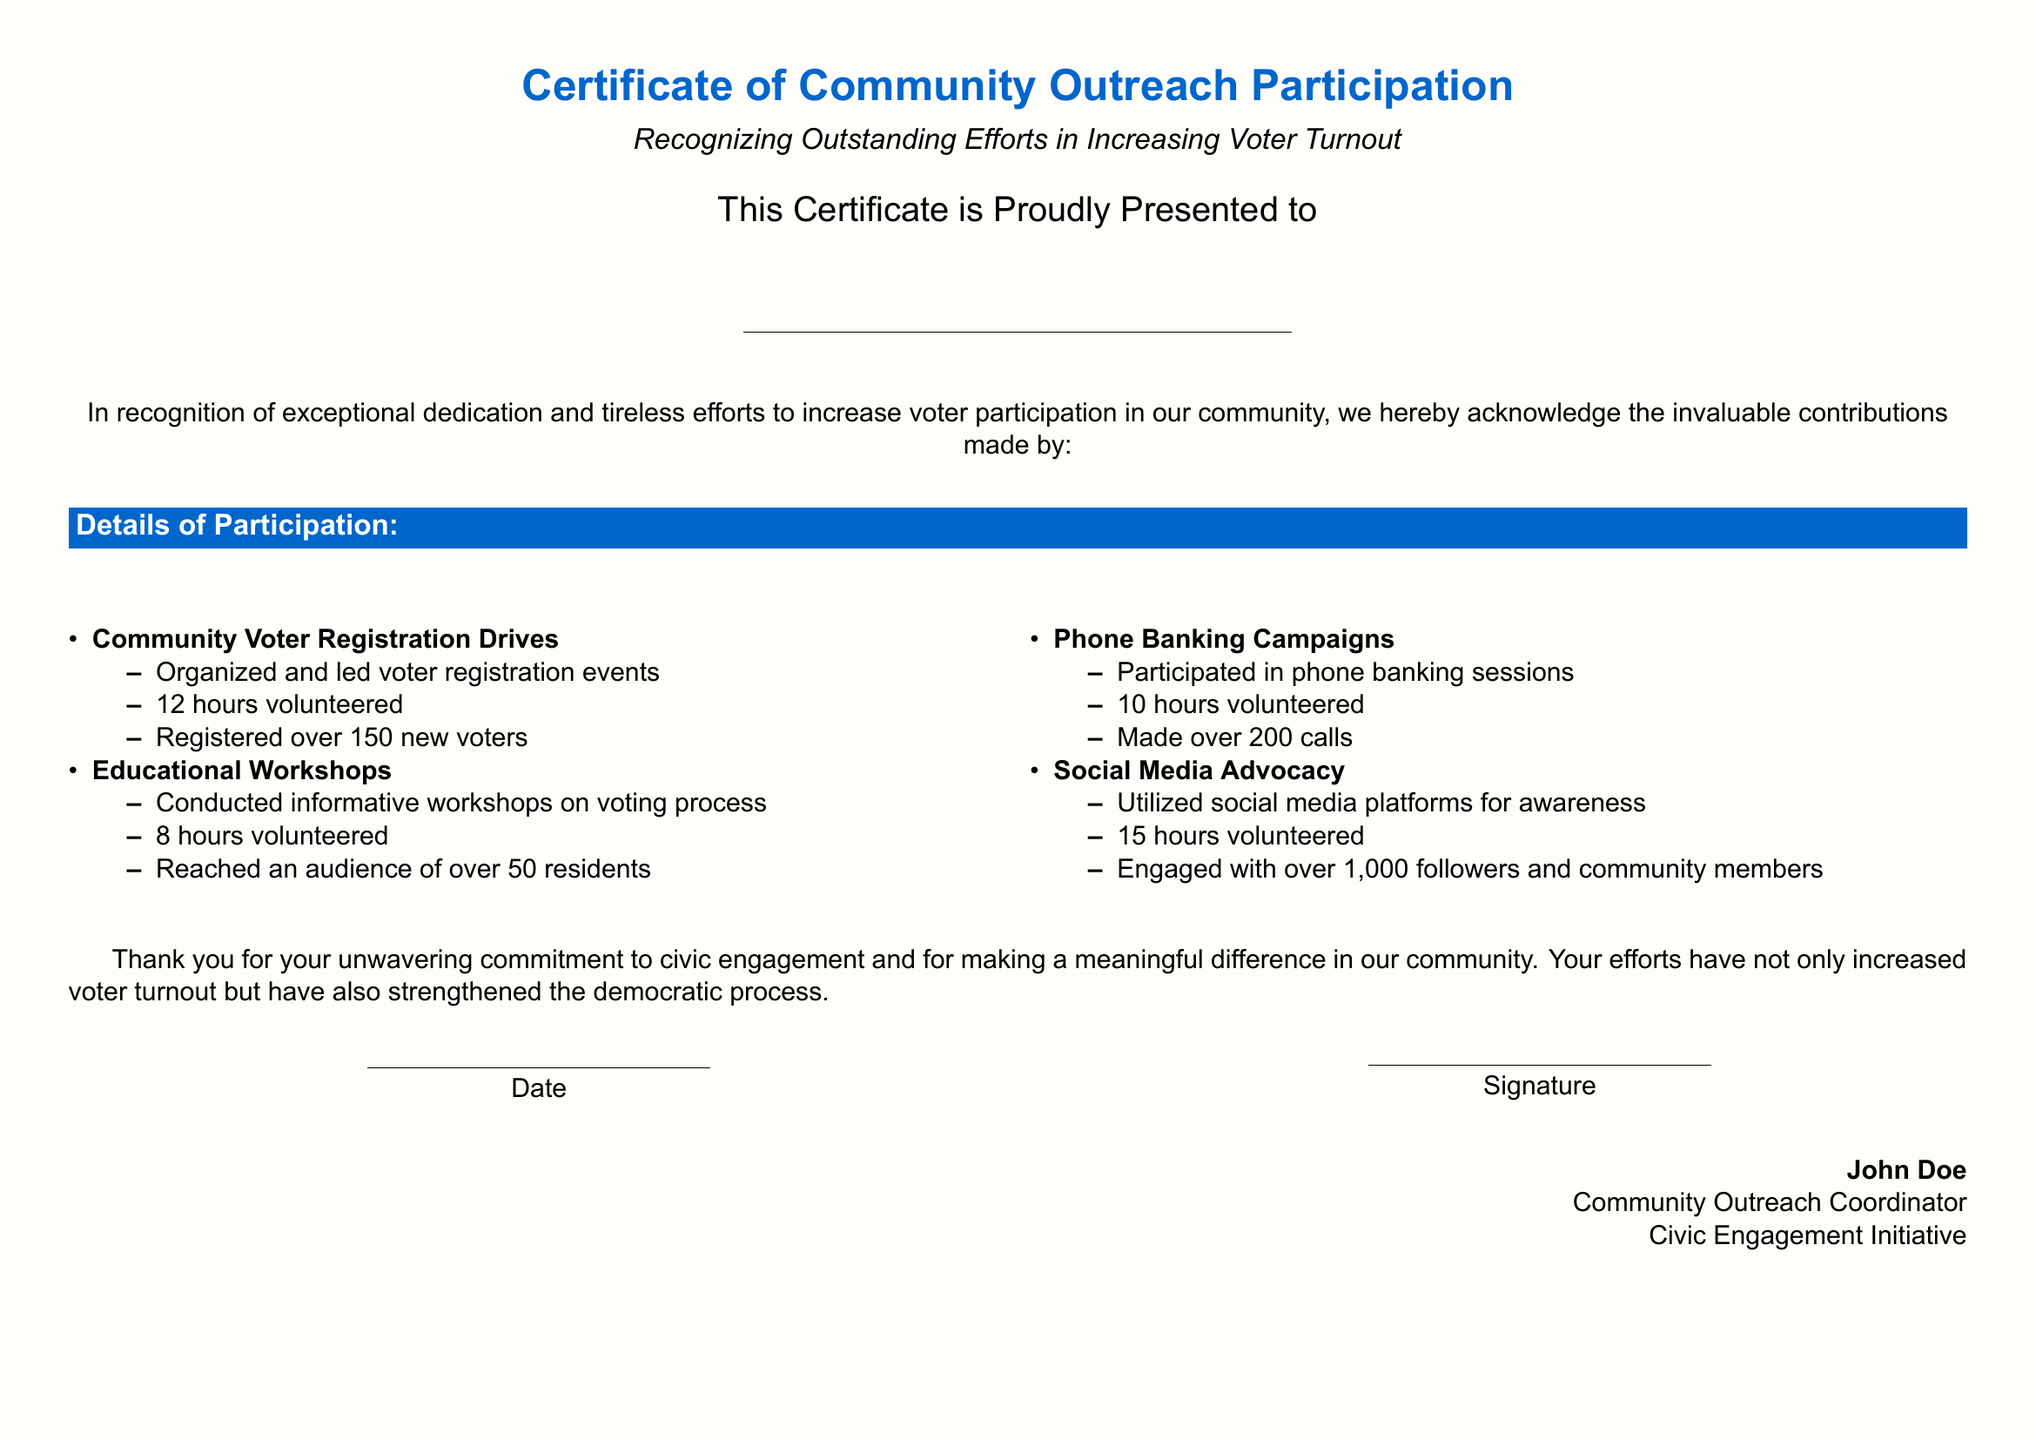what is the title of the certificate? The title is prominently displayed at the top of the certificate.
Answer: Certificate of Community Outreach Participation who is this certificate presented to? There is a designated space meant for the name of the individual receiving the certificate.
Answer: Name how many hours were volunteered for community voter registration drives? The document lists the hours contributed for each activity.
Answer: 12 hours how many new voters were registered during the voter registration drives? The certificate states the outcome of the voter registration efforts.
Answer: over 150 new voters what was the total number of calls made during the phone banking campaigns? The certificate specifies the results from the phone banking sessions.
Answer: over 200 calls who is the Community Outreach Coordinator? The coordinator's name is mentioned at the end of the document.
Answer: John Doe what is the purpose of the certificate as stated in the document? The purpose is summarized in the initial description of the certificate.
Answer: Recognizing Outstanding Efforts in Increasing Voter Turnout how many residents were reached during the educational workshops? The certificate provides a figure for the audience engagement in the workshops.
Answer: over 50 residents how many hours were volunteered for social media advocacy? The document explicitly states the time committed to this activity.
Answer: 15 hours 